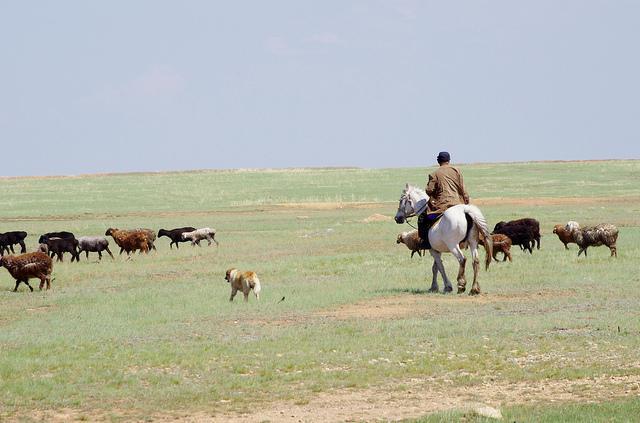How many men are there?
Give a very brief answer. 1. How many horses are there?
Give a very brief answer. 1. How many horses?
Give a very brief answer. 1. How many sheep can be seen?
Give a very brief answer. 1. How many train cars have some yellow on them?
Give a very brief answer. 0. 